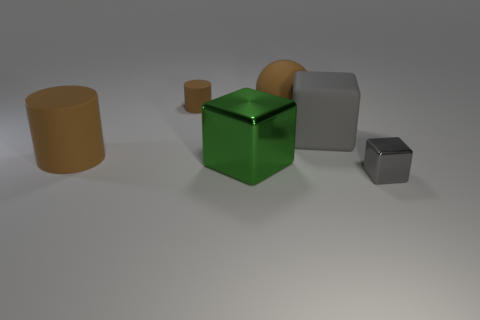There is a small brown thing; are there any large brown things behind it?
Give a very brief answer. No. How big is the object that is behind the matte block and right of the tiny brown thing?
Your answer should be very brief. Large. What number of things are rubber balls or large blue metallic cubes?
Offer a terse response. 1. There is a rubber ball; does it have the same size as the shiny object left of the gray matte object?
Ensure brevity in your answer.  Yes. There is a shiny cube in front of the large cube in front of the large thing that is on the left side of the large green thing; how big is it?
Provide a short and direct response. Small. Are there any blue spheres?
Provide a short and direct response. No. There is another block that is the same color as the matte block; what is its material?
Make the answer very short. Metal. What number of big things are the same color as the big rubber cube?
Ensure brevity in your answer.  0. What number of objects are either gray objects behind the gray shiny thing or brown objects left of the large rubber sphere?
Provide a succinct answer. 3. There is a big matte thing that is to the right of the big brown sphere; how many large brown cylinders are to the right of it?
Give a very brief answer. 0. 